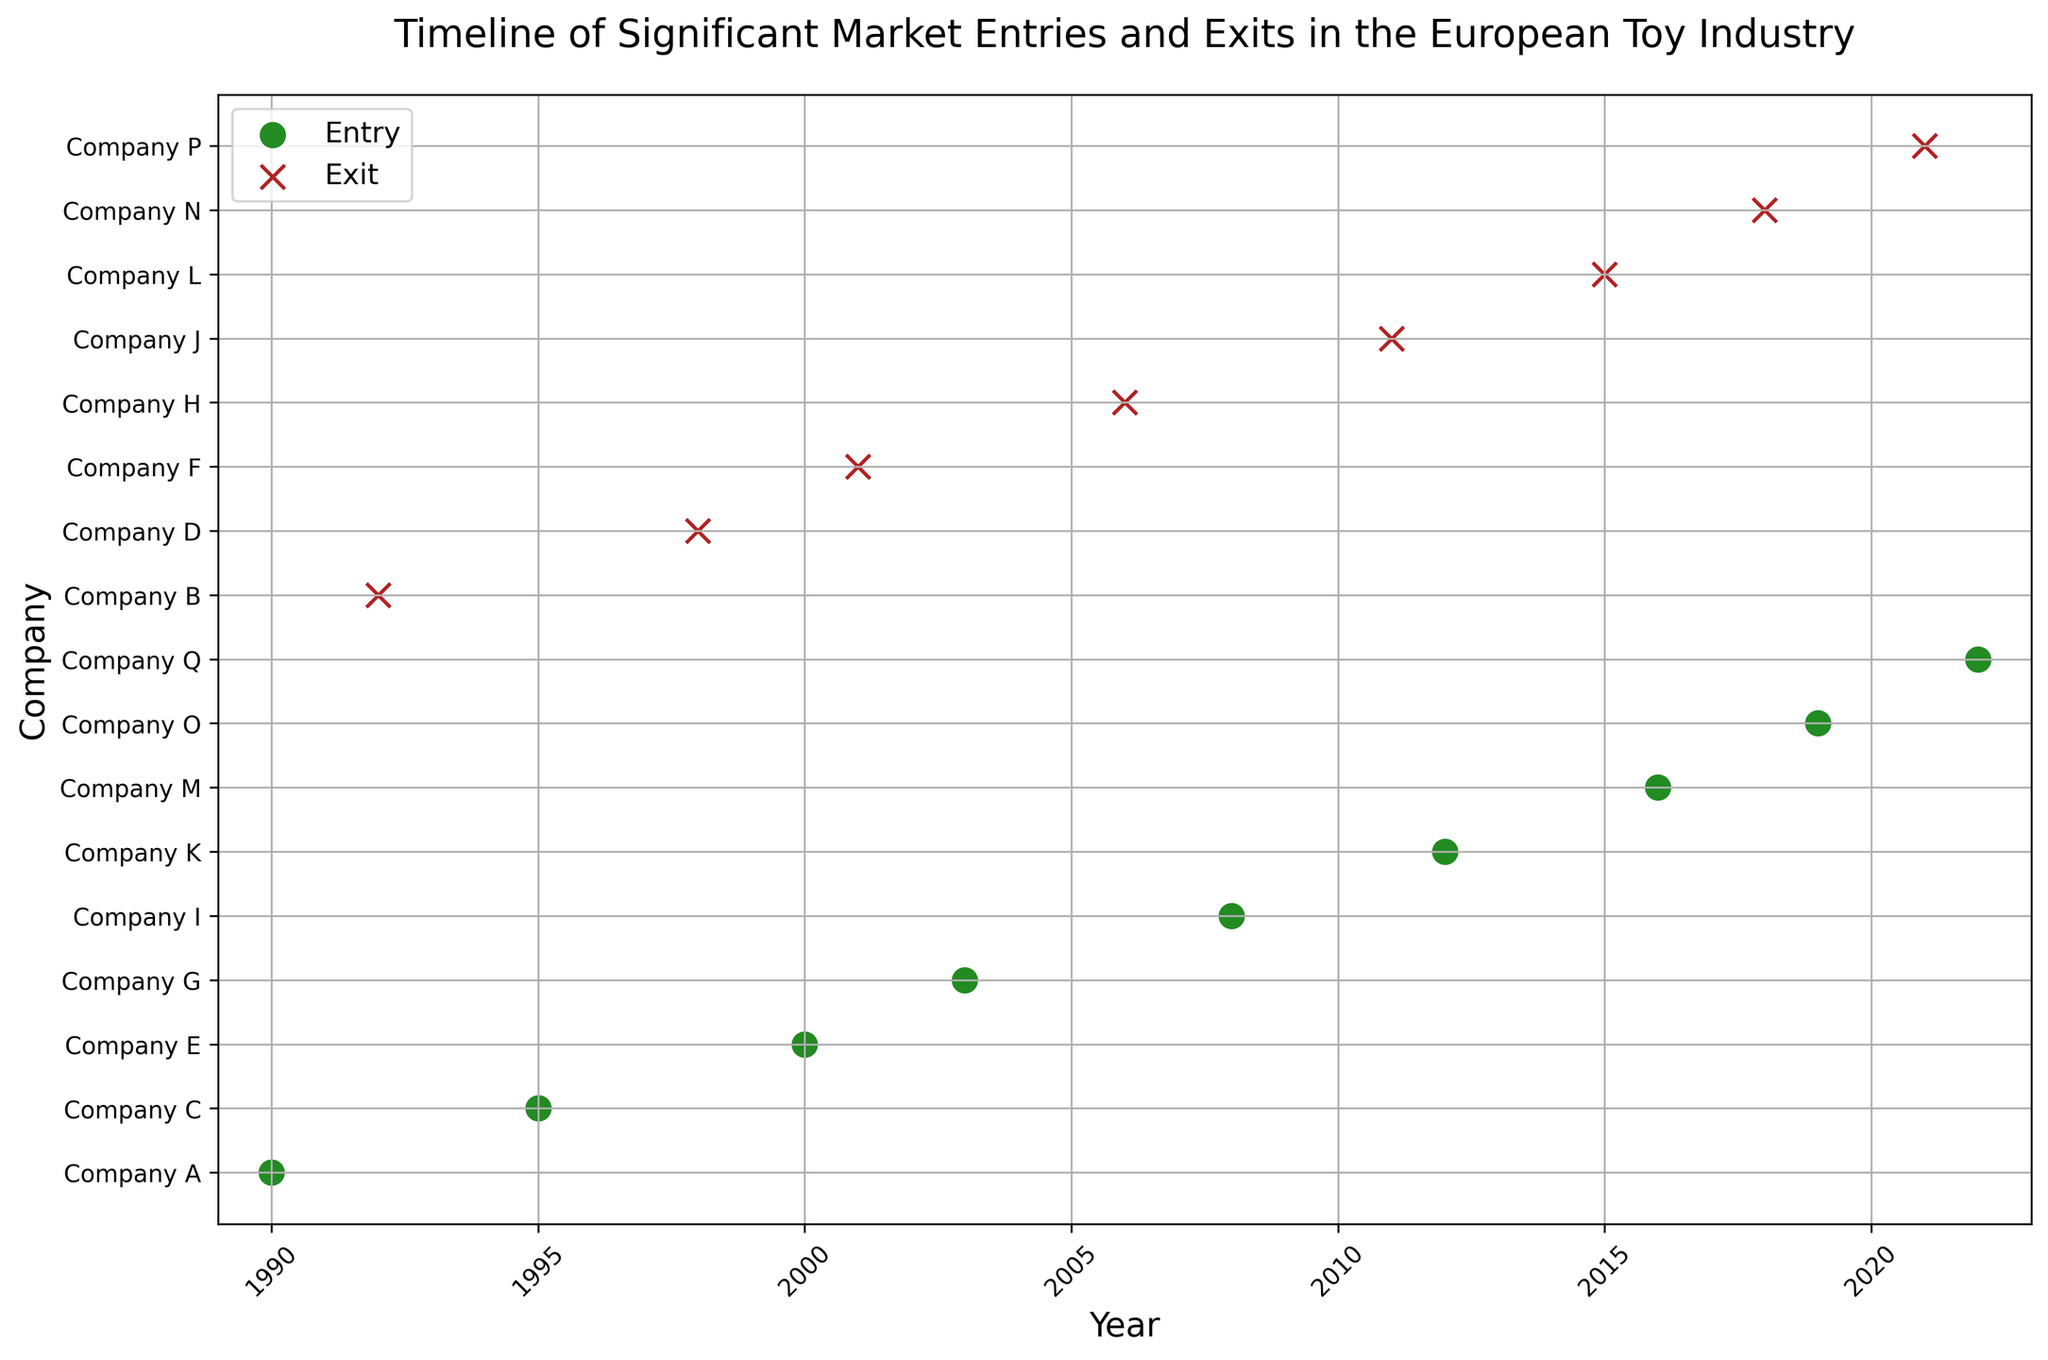Which company was the first to enter the market in the given timeline? The first entry in the timeline occurs in 1990, where Company A entered the market.
Answer: Company A Between which years did the longest period without any market entries occur? From visual inspection, the longest gap between entries appears between 2019 (entry of Company O) and 2022 (entry of Company Q), lasting 3 years.
Answer: 2019 to 2022 How many companies exited the market in the 2010s? The exits in the 2010s include Company J in 2011, Company L in 2015, and Company N in 2018, making a total of 3 exits.
Answer: 3 Which has more occurrences in the timeline, entries or exits? By counting, there are 9 entries (1990-2022) and 8 exits (1992-2021), so entries occur more frequently.
Answer: Entries Which years saw both an entry and an exit by different companies? The only year in which both an entry and an exit occurred is 2001 (entry of Company G and exit of Company H).
Answer: 2001 What is the color used to represent market entries? The color used for entries is green (forestgreen).
Answer: Green During which year did Company F exit the market? According to the timeline, Company F exited the market in the year 2001.
Answer: 2001 How many years are there between the entry of Company C and the exit of Company J? Company C entered in 1995 and Company J exited in 2011. The number of years between these events is 2011 - 1995 = 16 years.
Answer: 16 years Which event happened more recently in the timeline, the entry of Company M or the exit of Company N? Company M entered in 2016, and Company N exited in 2018. The exit of Company N is more recent.
Answer: Exit of Company N Is the entry of Company Q the most recent event in the timeline? Company Q's entry in 2022 is the last event on the timeline, making it the most recent.
Answer: Yes 